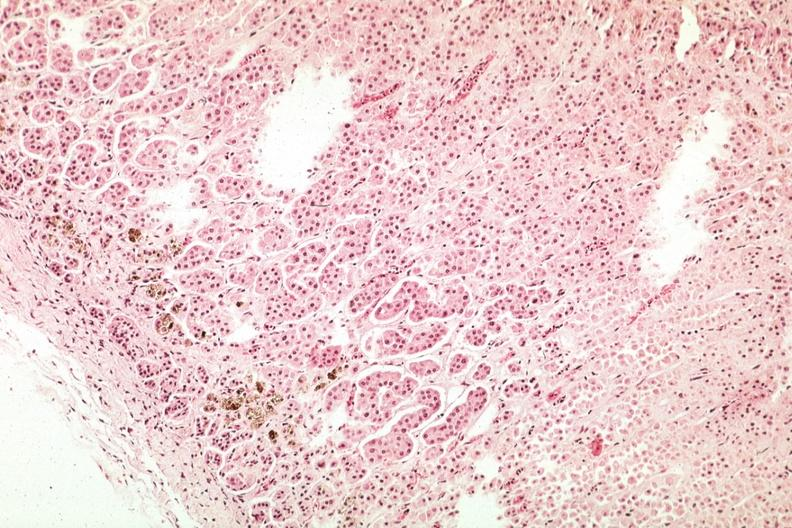s hemochromatosis present?
Answer the question using a single word or phrase. Yes 